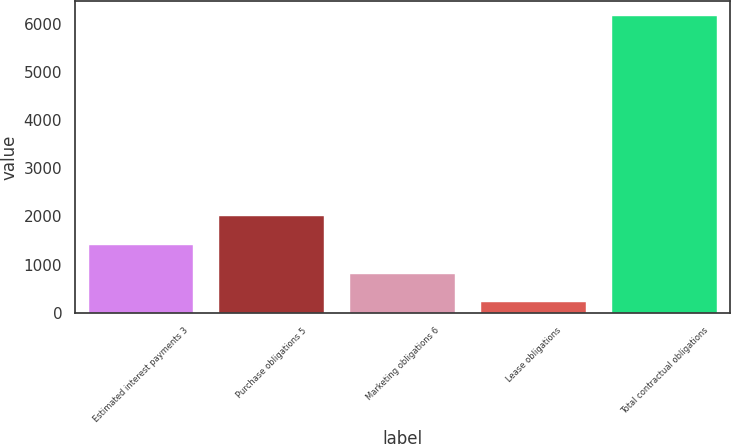<chart> <loc_0><loc_0><loc_500><loc_500><bar_chart><fcel>Estimated interest payments 3<fcel>Purchase obligations 5<fcel>Marketing obligations 6<fcel>Lease obligations<fcel>Total contractual obligations<nl><fcel>1406<fcel>2000<fcel>812<fcel>218<fcel>6158<nl></chart> 